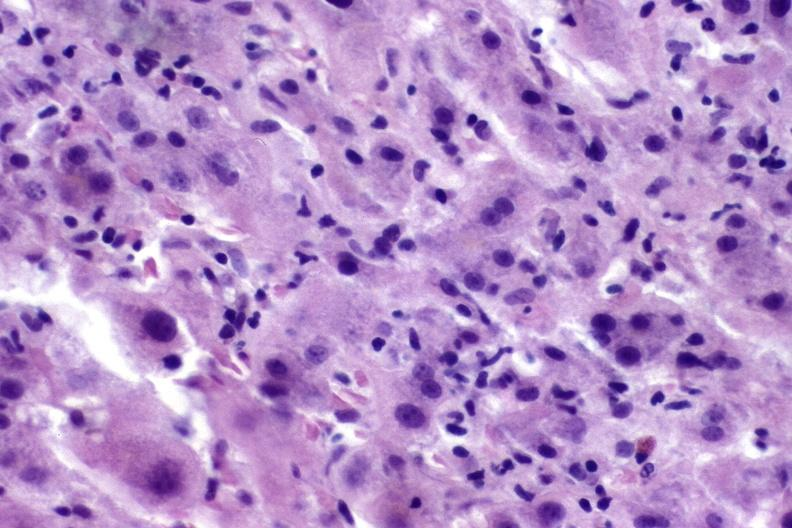s umbilical cord present?
Answer the question using a single word or phrase. No 